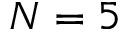<formula> <loc_0><loc_0><loc_500><loc_500>N = 5</formula> 